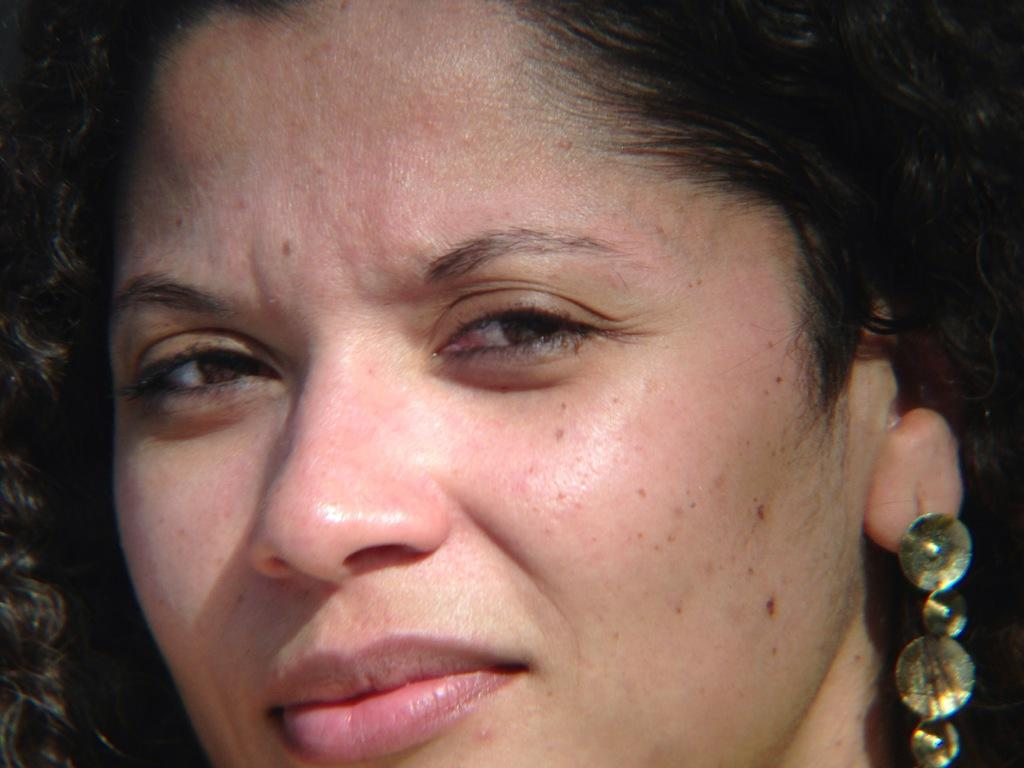Who is the main subject in the image? There is a woman in the image. What is a noticeable feature of the woman's appearance? The woman has black hair. What type of accessory is the woman wearing? The woman is wearing earrings. What type of cracker is the woman holding in the image? There is no cracker present in the image. What scene is depicted in the background of the image? The image does not show a scene in the background; it only features the woman. 